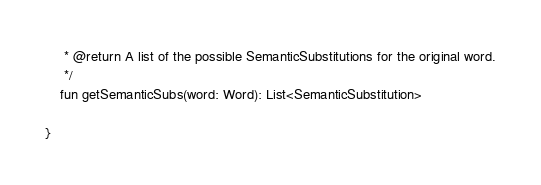<code> <loc_0><loc_0><loc_500><loc_500><_Kotlin_>     * @return A list of the possible SemanticSubstitutions for the original word.
     */
    fun getSemanticSubs(word: Word): List<SemanticSubstitution>

}</code> 